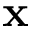Convert formula to latex. <formula><loc_0><loc_0><loc_500><loc_500>x</formula> 